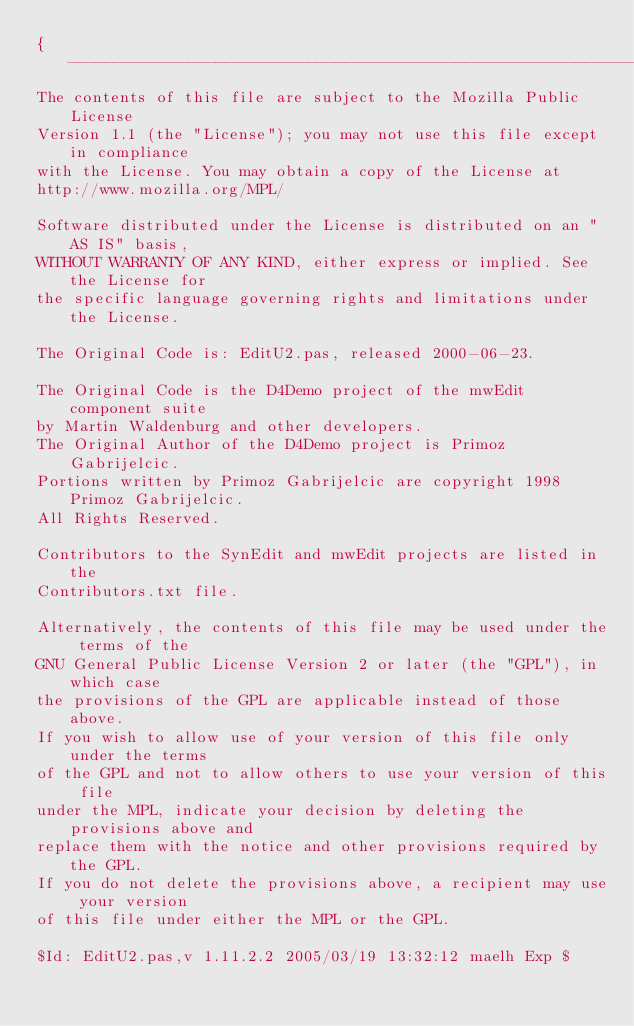<code> <loc_0><loc_0><loc_500><loc_500><_Pascal_>{-------------------------------------------------------------------------------
The contents of this file are subject to the Mozilla Public License
Version 1.1 (the "License"); you may not use this file except in compliance
with the License. You may obtain a copy of the License at
http://www.mozilla.org/MPL/

Software distributed under the License is distributed on an "AS IS" basis,
WITHOUT WARRANTY OF ANY KIND, either express or implied. See the License for
the specific language governing rights and limitations under the License.

The Original Code is: EditU2.pas, released 2000-06-23.

The Original Code is the D4Demo project of the mwEdit component suite
by Martin Waldenburg and other developers.
The Original Author of the D4Demo project is Primoz Gabrijelcic.
Portions written by Primoz Gabrijelcic are copyright 1998 Primoz Gabrijelcic.
All Rights Reserved.

Contributors to the SynEdit and mwEdit projects are listed in the
Contributors.txt file.

Alternatively, the contents of this file may be used under the terms of the
GNU General Public License Version 2 or later (the "GPL"), in which case
the provisions of the GPL are applicable instead of those above.
If you wish to allow use of your version of this file only under the terms
of the GPL and not to allow others to use your version of this file
under the MPL, indicate your decision by deleting the provisions above and
replace them with the notice and other provisions required by the GPL.
If you do not delete the provisions above, a recipient may use your version
of this file under either the MPL or the GPL.

$Id: EditU2.pas,v 1.11.2.2 2005/03/19 13:32:12 maelh Exp $
</code> 